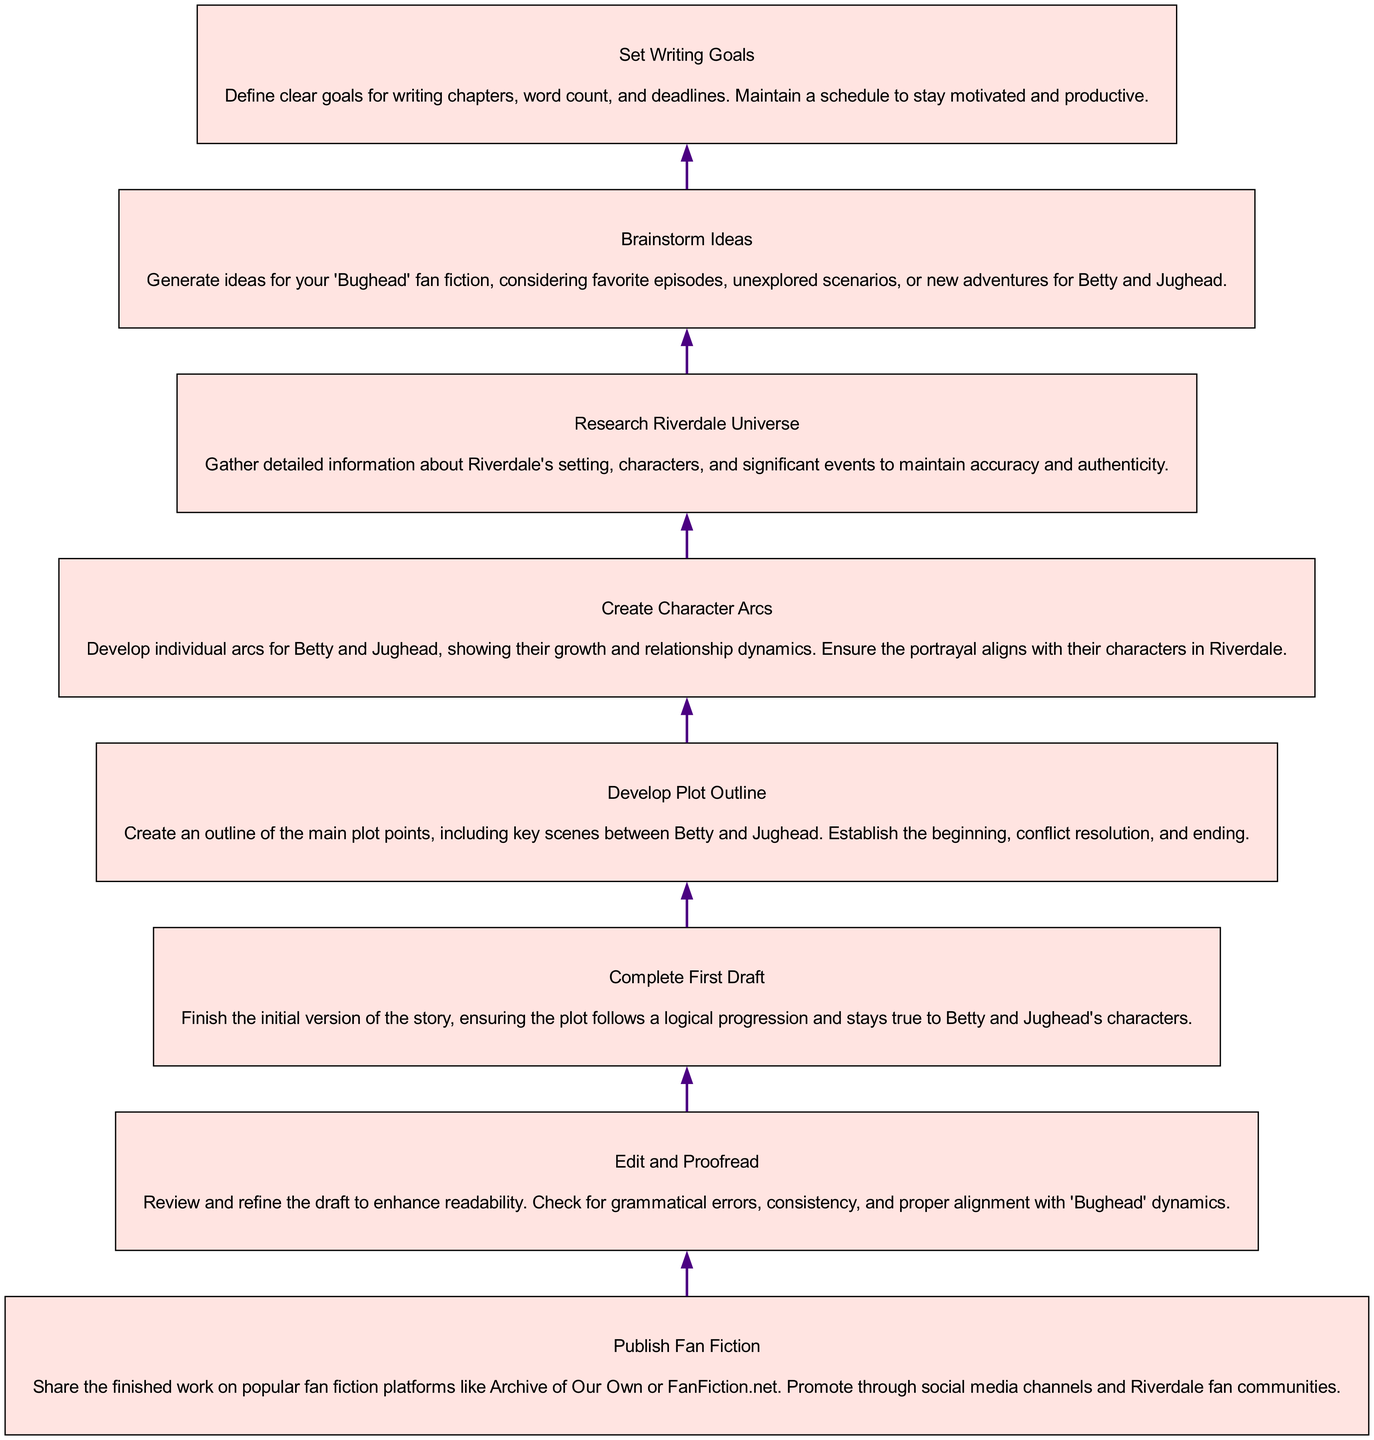What is the final step in the diagram? The final step indicated at the top of the flow chart is "Publish Fan Fiction." This is the last action that wraps up the entire process of writing and publishing a fan fiction story about 'Bughead.'
Answer: Publish Fan Fiction How many main steps are in the diagram? Counting the elements in the diagram, there are a total of eight steps that outline the process, starting from brainstorming ideas down to publishing the fan fiction.
Answer: Eight What is the step before "Edit and Proofread"? The step directly before "Edit and Proofread" is "Complete First Draft." This indicates that once the first draft is completed, the next action is to edit and proofread the work.
Answer: Complete First Draft What is the purpose of "Research Riverdale Universe"? "Research Riverdale Universe" serves to gather essential information regarding the show's settings, characters, and events to ensure the fan fiction's accuracy and authenticity. This foundational research is crucial for writing a quality story.
Answer: Maintain accuracy and authenticity Which step involves defining goals for writing? The step titled "Set Writing Goals" focuses on defining clear objectives such as chapter goals, word count, and deadlines, intending to keep the writer motivated and on schedule throughout the writing process.
Answer: Set Writing Goals What is the relationship between "Develop Plot Outline" and "Create Character Arcs"? "Develop Plot Outline" and "Create Character Arcs" are both foundational steps in the writing process. They relate in that outlining the plot provides the structure for the story, while character arcs define the individual growth of Betty and Jughead within that framework. Both need to be coherent to create a strong story.
Answer: Foundational steps What is required before publishing the fan fiction? Before publishing the fan fiction, one must complete the editing and proofreading phase, ensuring the draft is refined and free of errors, which is crucial for readability and overall quality of the work.
Answer: Edit and Proofread What step follows "Brainstorm Ideas"? The next step after "Brainstorm Ideas" is "Research Riverdale Universe." This ensures that ideas generated are based on accurate knowledge of the characters and settings from the show, providing a solid foundation for the fan fiction.
Answer: Research Riverdale Universe 